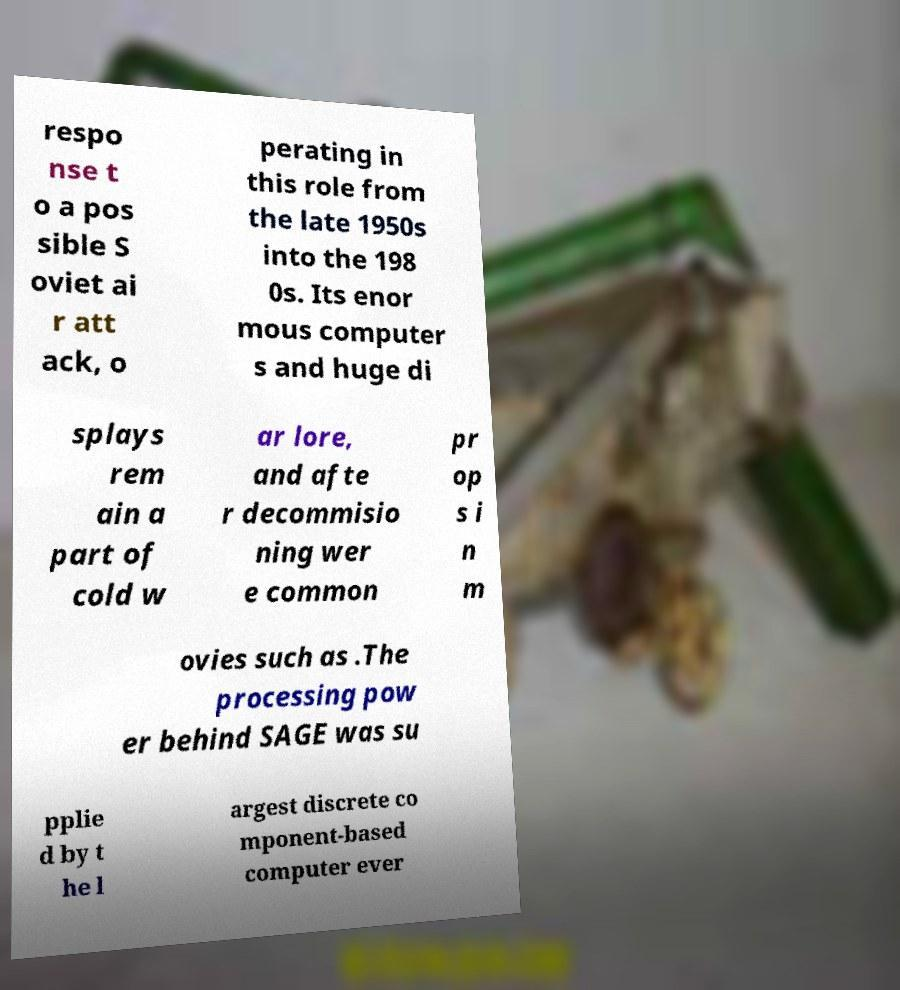Could you extract and type out the text from this image? respo nse t o a pos sible S oviet ai r att ack, o perating in this role from the late 1950s into the 198 0s. Its enor mous computer s and huge di splays rem ain a part of cold w ar lore, and afte r decommisio ning wer e common pr op s i n m ovies such as .The processing pow er behind SAGE was su pplie d by t he l argest discrete co mponent-based computer ever 